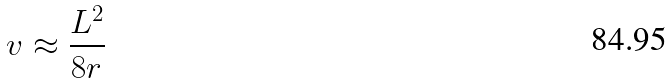<formula> <loc_0><loc_0><loc_500><loc_500>v \approx \frac { L ^ { 2 } } { 8 r }</formula> 